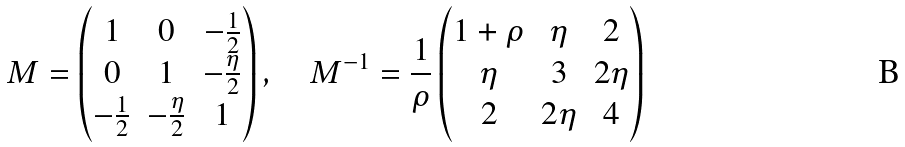Convert formula to latex. <formula><loc_0><loc_0><loc_500><loc_500>M = \begin{pmatrix} 1 & 0 & - \frac { 1 } { 2 } \\ 0 & 1 & - \frac { \eta } { 2 } \\ - \frac { 1 } { 2 } & - \frac { \eta } { 2 } & 1 \end{pmatrix} , \quad M ^ { - 1 } = \frac { 1 } { \rho } \begin{pmatrix} 1 + \rho & \eta & 2 \\ \eta & 3 & 2 \eta \\ 2 & 2 \eta & 4 \end{pmatrix}</formula> 